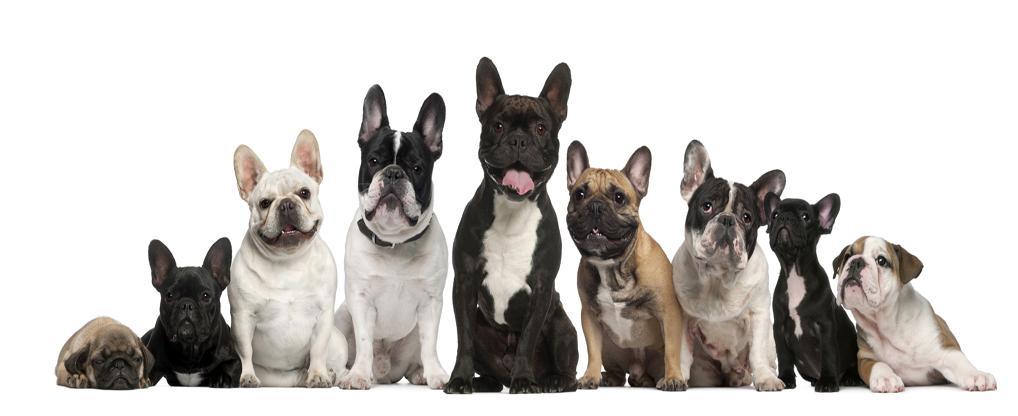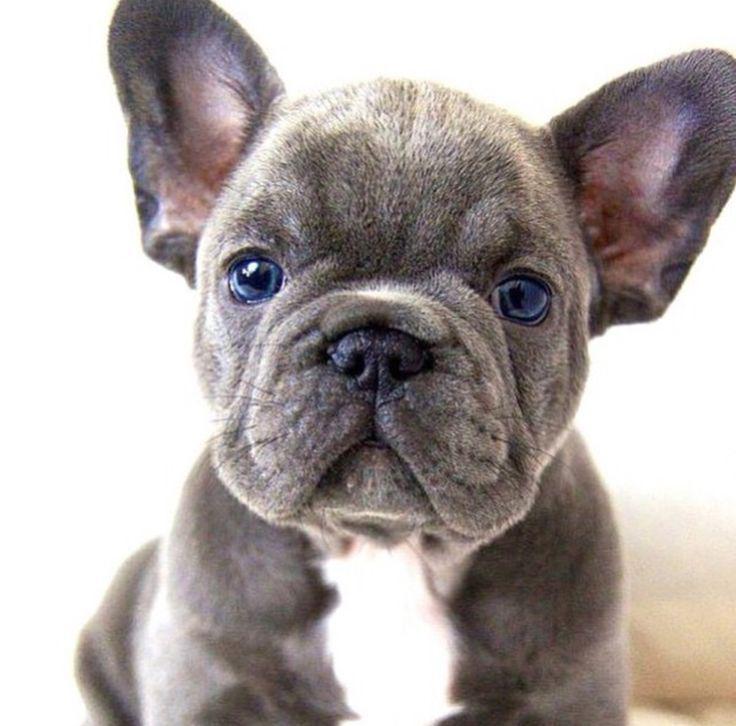The first image is the image on the left, the second image is the image on the right. Considering the images on both sides, is "One dog is standing and one is lying down, neither wearing a collar." valid? Answer yes or no. No. The first image is the image on the left, the second image is the image on the right. Analyze the images presented: Is the assertion "An image shows one puppy standing outdoors, in profile, turned rightward." valid? Answer yes or no. No. 